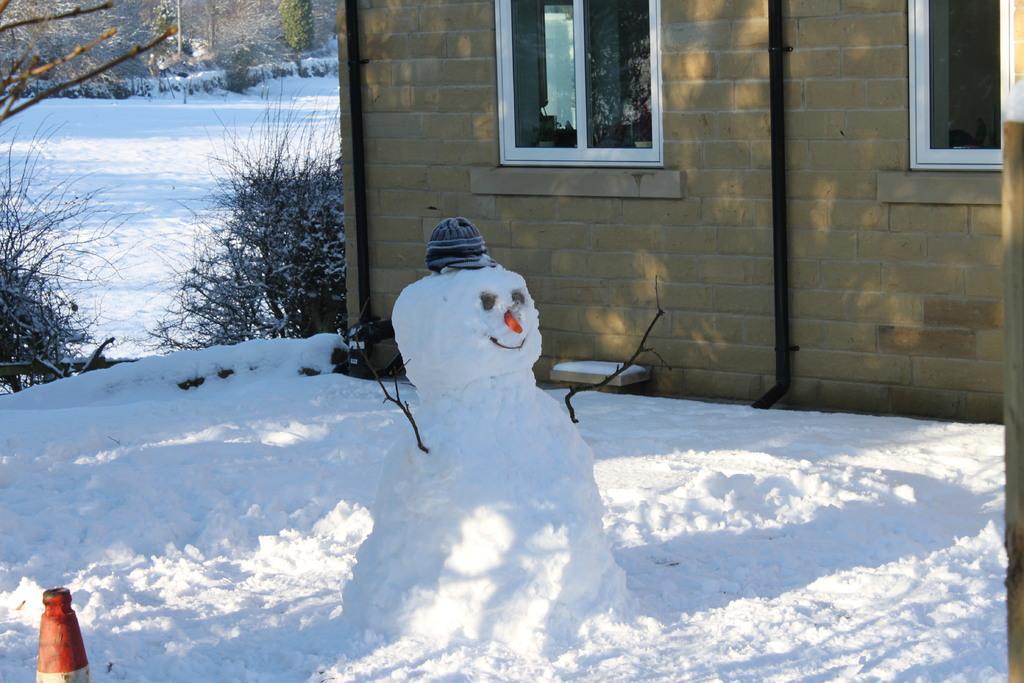Can you describe this image briefly? In this picture we can see a snow toy, here we can see a traffic cone, house with windows, snow and in the background we can see trees. 